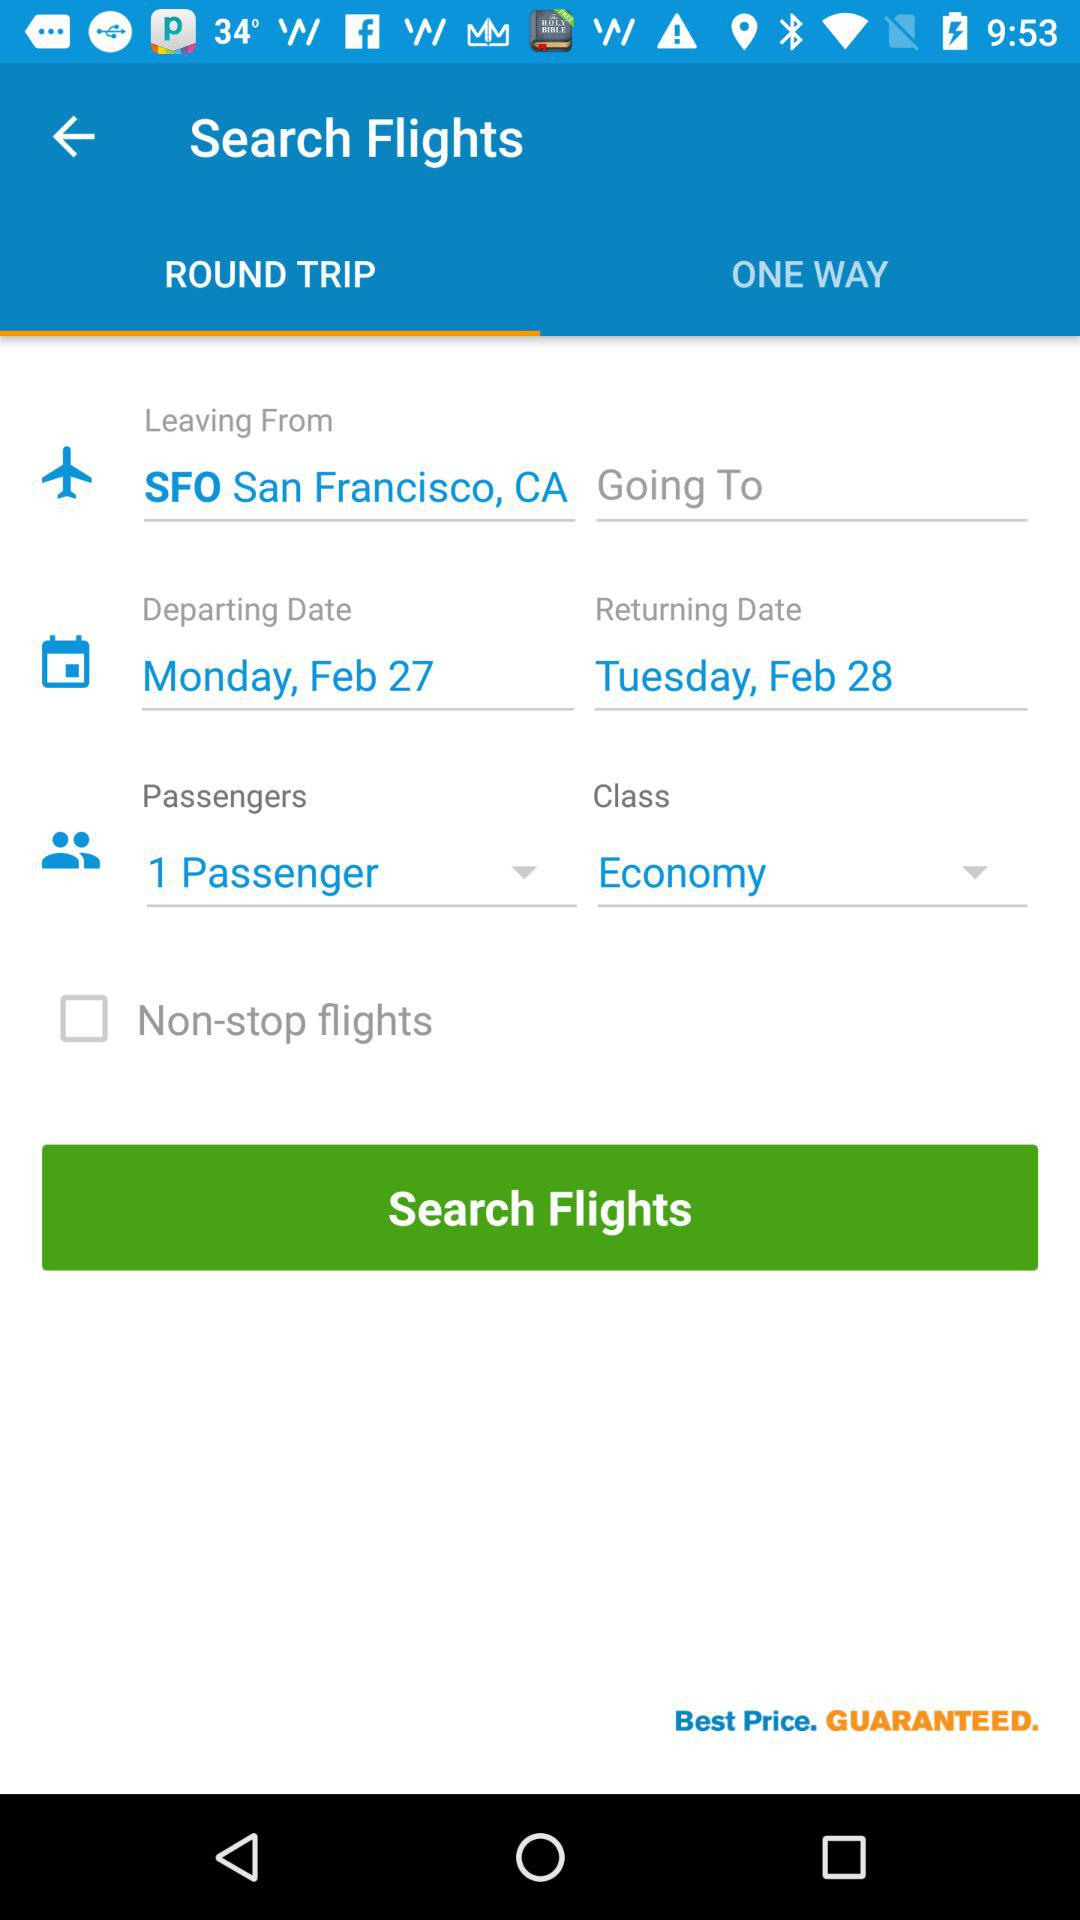What is the selected number of passengers? The selected number of passengers is 1. 